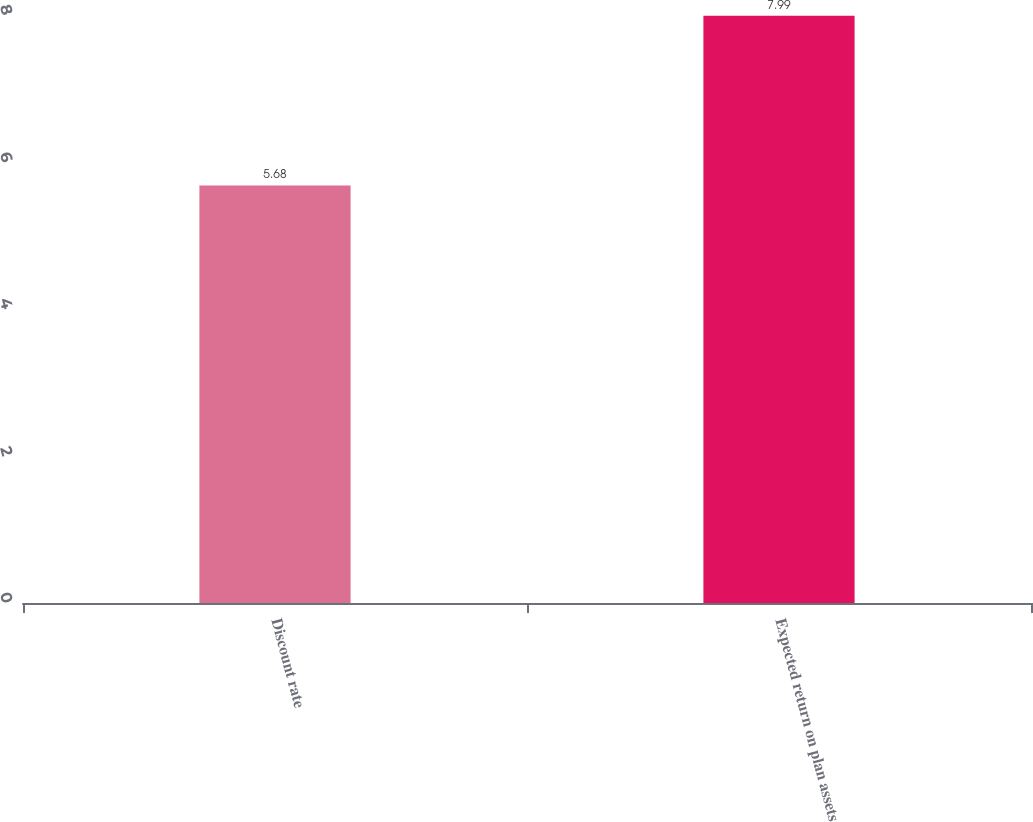Convert chart to OTSL. <chart><loc_0><loc_0><loc_500><loc_500><bar_chart><fcel>Discount rate<fcel>Expected return on plan assets<nl><fcel>5.68<fcel>7.99<nl></chart> 